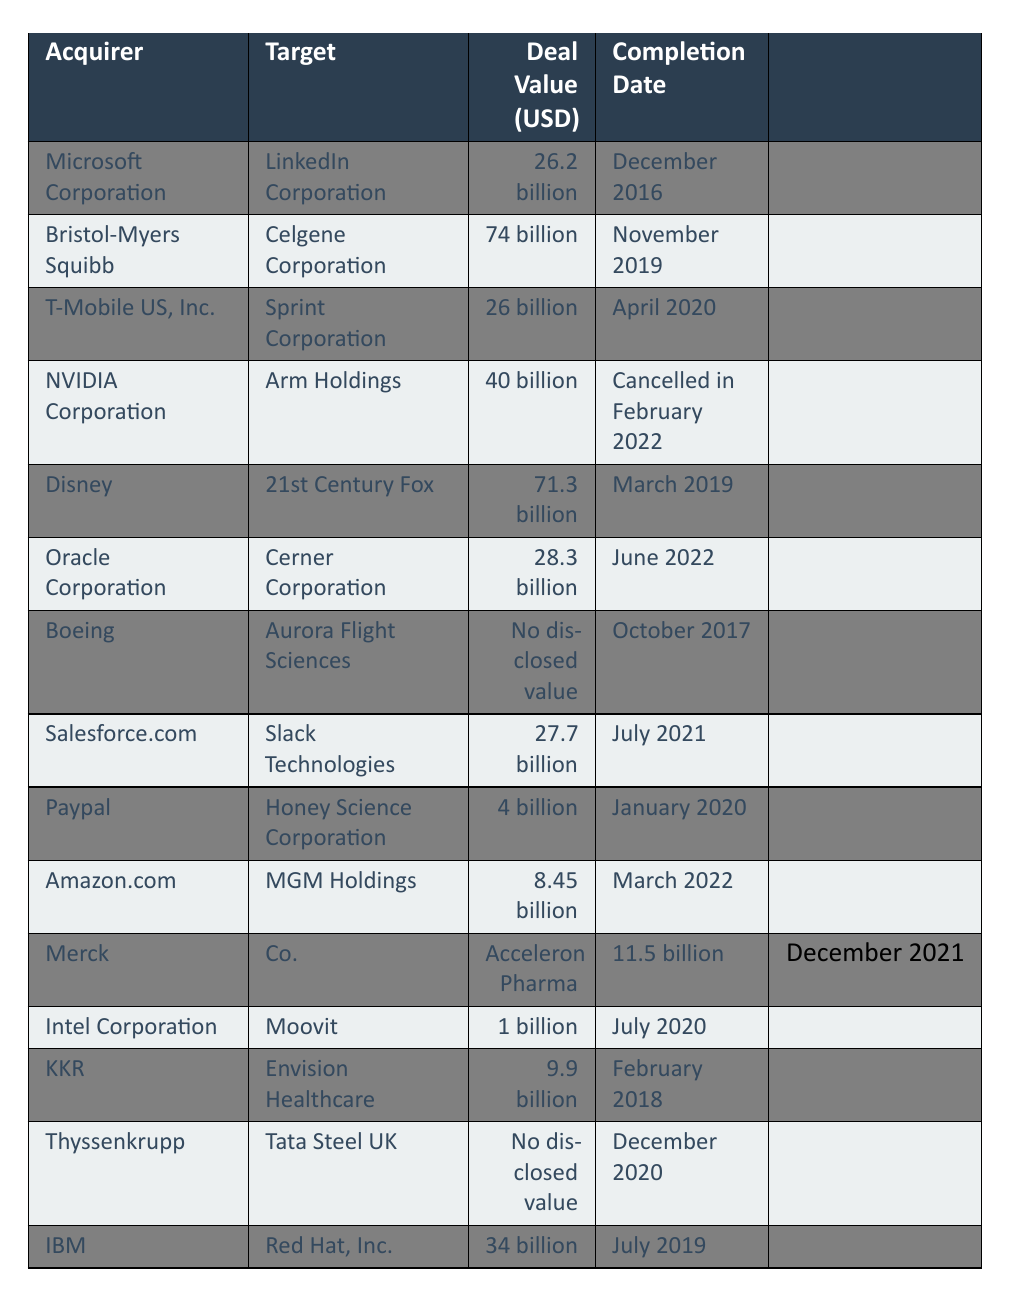What is the deal value of the acquisition between Microsoft Corporation and LinkedIn Corporation? The table shows that the deal value for the acquisition between Microsoft Corporation and LinkedIn Corporation is 26.2 billion.
Answer: 26.2 billion Which acquisition had the highest deal value? By reviewing the table, the highest deal value is associated with Bristol-Myers Squibb acquiring Celgene Corporation, which is listed as 74 billion.
Answer: 74 billion How many acquisitions have deal values disclosed as 'No disclosed value'? The table indicates that there are two acquisitions with 'No disclosed value': Boeing acquiring Aurora Flight Sciences and Thyssenkrupp acquiring Tata Steel UK.
Answer: 2 What is the total deal value of all acquisitions listed, excluding those with no disclosed value? To find the total deal value, we need to sum the amounts of all acquisitions with disclosed values: 26.2 + 74 + 26 + 40 + 71.3 + 28.3 + 27.7 + 4 + 8.45 + 11.5 + 1 + 9.9 + 34. The total is 342.65 billion.
Answer: 342.65 billion When was the acquisition of Slack Technologies by Salesforce.com completed? According to the table, the acquisition of Slack Technologies by Salesforce.com was completed in July 2021.
Answer: July 2021 Which two companies were involved in the acquisition with the deal value of 40 billion? The table shows that NVIDIA Corporation acquired Arm Holdings for a deal value of 40 billion.
Answer: NVIDIA Corporation and Arm Holdings Is there an acquisition that was cancelled, and what was its deal value? Yes, the acquisition by NVIDIA Corporation of Arm Holdings was cancelled, and its deal value was 40 billion.
Answer: Yes, 40 billion What is the average deal value of the acquisitions completed in 2022? The only acquisitions completed in 2022 are Oracle's acquisition of Cerner Corporation (28.3 billion), Amazon's acquisition of MGM Holdings (8.45 billion), and Merck & Co.'s acquisition of Acceleron Pharma (11.5 billion). To find the average: (28.3 + 8.45 + 11.5) / 3 = 16.08 billion.
Answer: 16.08 billion In which month was the acquisition completed between Amazon.com and MGM Holdings? The table specifies that the acquisition between Amazon.com and MGM Holdings was completed in March 2022.
Answer: March 2022 What is the deal value of the acquisition made by Paypal? The table lists the deal value of Paypal's acquisition of Honey Science Corporation as 4 billion.
Answer: 4 billion What percentage of the acquisitions listed have a deal value exceeding 25 billion? The acquisitions exceeding 25 billion are: Microsoft with 26.2, Bristol-Myers Squibb with 74, T-Mobile US with 26, Disney with 71.3, Oracle with 28.3, Salesforce.com with 27.7, and IBM with 34. That makes 7 out of 15 total acquisitions. The percentage is (7/15) * 100 = 46.67%.
Answer: 46.67% 